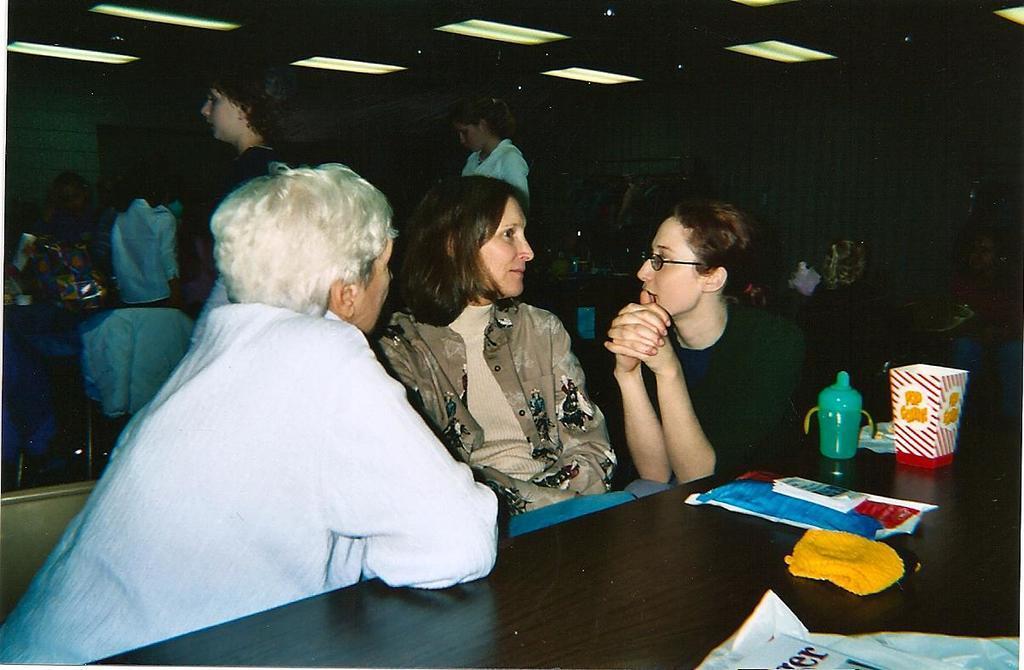Please provide a concise description of this image. In this image,there is a table in front of this person's. This table contains bottle, cup and notebook. There are two persons standing behind these persons. This person is wearing spectacles. There are some lights at the top. 